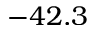<formula> <loc_0><loc_0><loc_500><loc_500>- 4 2 . 3</formula> 